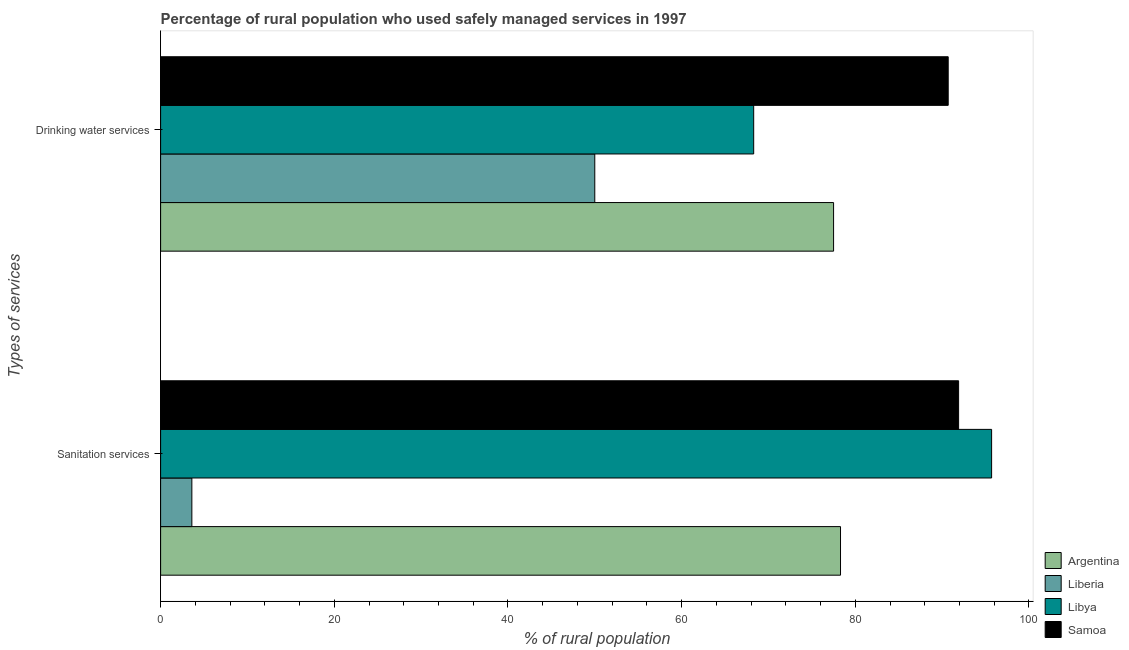How many groups of bars are there?
Offer a terse response. 2. Are the number of bars on each tick of the Y-axis equal?
Offer a terse response. Yes. How many bars are there on the 2nd tick from the top?
Provide a succinct answer. 4. What is the label of the 2nd group of bars from the top?
Offer a very short reply. Sanitation services. What is the percentage of rural population who used drinking water services in Samoa?
Your answer should be very brief. 90.7. Across all countries, what is the maximum percentage of rural population who used sanitation services?
Give a very brief answer. 95.7. In which country was the percentage of rural population who used sanitation services maximum?
Ensure brevity in your answer.  Libya. In which country was the percentage of rural population who used sanitation services minimum?
Offer a terse response. Liberia. What is the total percentage of rural population who used drinking water services in the graph?
Your answer should be very brief. 286.5. What is the difference between the percentage of rural population who used sanitation services in Argentina and that in Samoa?
Offer a very short reply. -13.6. What is the difference between the percentage of rural population who used drinking water services in Liberia and the percentage of rural population who used sanitation services in Samoa?
Offer a very short reply. -41.9. What is the average percentage of rural population who used drinking water services per country?
Provide a succinct answer. 71.62. What is the difference between the percentage of rural population who used sanitation services and percentage of rural population who used drinking water services in Argentina?
Ensure brevity in your answer.  0.8. What is the ratio of the percentage of rural population who used sanitation services in Argentina to that in Samoa?
Offer a terse response. 0.85. What does the 2nd bar from the top in Sanitation services represents?
Offer a terse response. Libya. How many bars are there?
Give a very brief answer. 8. How many countries are there in the graph?
Provide a succinct answer. 4. What is the difference between two consecutive major ticks on the X-axis?
Your answer should be very brief. 20. Are the values on the major ticks of X-axis written in scientific E-notation?
Ensure brevity in your answer.  No. Where does the legend appear in the graph?
Offer a very short reply. Bottom right. How many legend labels are there?
Give a very brief answer. 4. How are the legend labels stacked?
Your response must be concise. Vertical. What is the title of the graph?
Ensure brevity in your answer.  Percentage of rural population who used safely managed services in 1997. What is the label or title of the X-axis?
Offer a terse response. % of rural population. What is the label or title of the Y-axis?
Offer a terse response. Types of services. What is the % of rural population of Argentina in Sanitation services?
Provide a short and direct response. 78.3. What is the % of rural population in Libya in Sanitation services?
Ensure brevity in your answer.  95.7. What is the % of rural population in Samoa in Sanitation services?
Keep it short and to the point. 91.9. What is the % of rural population in Argentina in Drinking water services?
Keep it short and to the point. 77.5. What is the % of rural population of Liberia in Drinking water services?
Your response must be concise. 50. What is the % of rural population in Libya in Drinking water services?
Make the answer very short. 68.3. What is the % of rural population in Samoa in Drinking water services?
Ensure brevity in your answer.  90.7. Across all Types of services, what is the maximum % of rural population in Argentina?
Give a very brief answer. 78.3. Across all Types of services, what is the maximum % of rural population of Liberia?
Make the answer very short. 50. Across all Types of services, what is the maximum % of rural population of Libya?
Provide a succinct answer. 95.7. Across all Types of services, what is the maximum % of rural population in Samoa?
Provide a succinct answer. 91.9. Across all Types of services, what is the minimum % of rural population in Argentina?
Provide a succinct answer. 77.5. Across all Types of services, what is the minimum % of rural population of Liberia?
Give a very brief answer. 3.6. Across all Types of services, what is the minimum % of rural population in Libya?
Provide a short and direct response. 68.3. Across all Types of services, what is the minimum % of rural population of Samoa?
Your answer should be very brief. 90.7. What is the total % of rural population of Argentina in the graph?
Your answer should be very brief. 155.8. What is the total % of rural population of Liberia in the graph?
Your answer should be very brief. 53.6. What is the total % of rural population of Libya in the graph?
Provide a short and direct response. 164. What is the total % of rural population of Samoa in the graph?
Offer a terse response. 182.6. What is the difference between the % of rural population in Argentina in Sanitation services and that in Drinking water services?
Give a very brief answer. 0.8. What is the difference between the % of rural population of Liberia in Sanitation services and that in Drinking water services?
Keep it short and to the point. -46.4. What is the difference between the % of rural population in Libya in Sanitation services and that in Drinking water services?
Keep it short and to the point. 27.4. What is the difference between the % of rural population in Argentina in Sanitation services and the % of rural population in Liberia in Drinking water services?
Provide a succinct answer. 28.3. What is the difference between the % of rural population of Liberia in Sanitation services and the % of rural population of Libya in Drinking water services?
Your answer should be very brief. -64.7. What is the difference between the % of rural population in Liberia in Sanitation services and the % of rural population in Samoa in Drinking water services?
Provide a short and direct response. -87.1. What is the difference between the % of rural population in Libya in Sanitation services and the % of rural population in Samoa in Drinking water services?
Make the answer very short. 5. What is the average % of rural population in Argentina per Types of services?
Your answer should be compact. 77.9. What is the average % of rural population of Liberia per Types of services?
Provide a succinct answer. 26.8. What is the average % of rural population of Samoa per Types of services?
Make the answer very short. 91.3. What is the difference between the % of rural population in Argentina and % of rural population in Liberia in Sanitation services?
Your response must be concise. 74.7. What is the difference between the % of rural population in Argentina and % of rural population in Libya in Sanitation services?
Ensure brevity in your answer.  -17.4. What is the difference between the % of rural population of Argentina and % of rural population of Samoa in Sanitation services?
Your response must be concise. -13.6. What is the difference between the % of rural population in Liberia and % of rural population in Libya in Sanitation services?
Offer a terse response. -92.1. What is the difference between the % of rural population in Liberia and % of rural population in Samoa in Sanitation services?
Your answer should be compact. -88.3. What is the difference between the % of rural population of Argentina and % of rural population of Liberia in Drinking water services?
Give a very brief answer. 27.5. What is the difference between the % of rural population in Argentina and % of rural population in Libya in Drinking water services?
Ensure brevity in your answer.  9.2. What is the difference between the % of rural population of Argentina and % of rural population of Samoa in Drinking water services?
Provide a succinct answer. -13.2. What is the difference between the % of rural population in Liberia and % of rural population in Libya in Drinking water services?
Your answer should be very brief. -18.3. What is the difference between the % of rural population of Liberia and % of rural population of Samoa in Drinking water services?
Your answer should be very brief. -40.7. What is the difference between the % of rural population in Libya and % of rural population in Samoa in Drinking water services?
Your answer should be compact. -22.4. What is the ratio of the % of rural population in Argentina in Sanitation services to that in Drinking water services?
Your response must be concise. 1.01. What is the ratio of the % of rural population of Liberia in Sanitation services to that in Drinking water services?
Keep it short and to the point. 0.07. What is the ratio of the % of rural population of Libya in Sanitation services to that in Drinking water services?
Provide a short and direct response. 1.4. What is the ratio of the % of rural population in Samoa in Sanitation services to that in Drinking water services?
Provide a succinct answer. 1.01. What is the difference between the highest and the second highest % of rural population in Argentina?
Your answer should be very brief. 0.8. What is the difference between the highest and the second highest % of rural population of Liberia?
Provide a short and direct response. 46.4. What is the difference between the highest and the second highest % of rural population in Libya?
Give a very brief answer. 27.4. What is the difference between the highest and the second highest % of rural population in Samoa?
Make the answer very short. 1.2. What is the difference between the highest and the lowest % of rural population of Argentina?
Give a very brief answer. 0.8. What is the difference between the highest and the lowest % of rural population of Liberia?
Offer a terse response. 46.4. What is the difference between the highest and the lowest % of rural population in Libya?
Your response must be concise. 27.4. What is the difference between the highest and the lowest % of rural population in Samoa?
Offer a terse response. 1.2. 